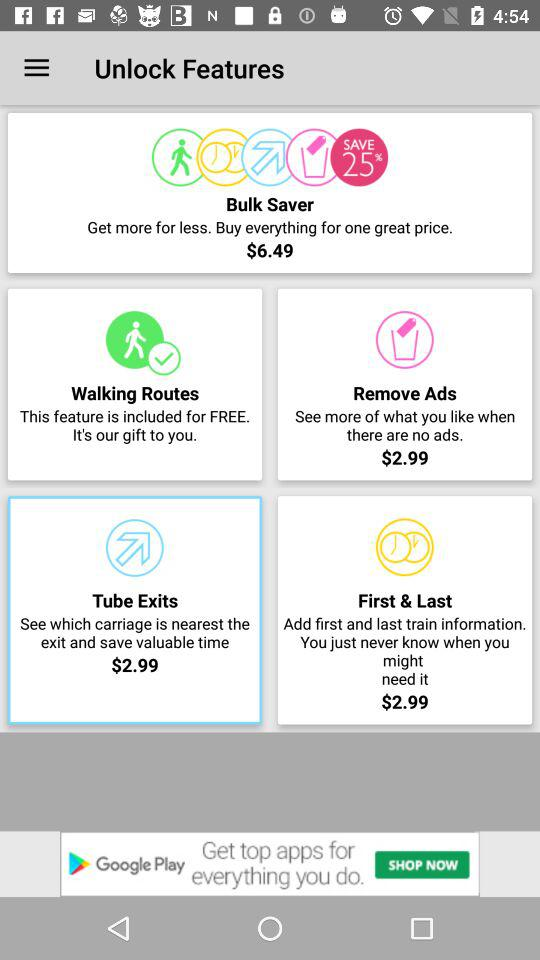How many features are there in total?
Answer the question using a single word or phrase. 4 